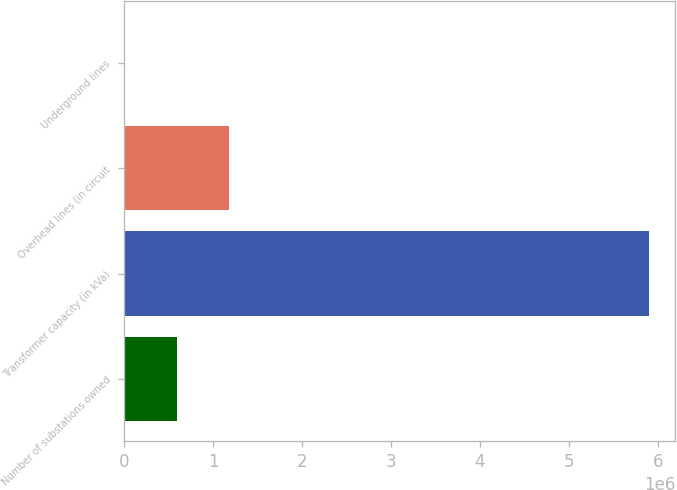Convert chart to OTSL. <chart><loc_0><loc_0><loc_500><loc_500><bar_chart><fcel>Number of substations owned<fcel>Transformer capacity (in kVa)<fcel>Overhead lines (in circuit<fcel>Underground lines<nl><fcel>590501<fcel>5.905e+06<fcel>1.181e+06<fcel>1<nl></chart> 